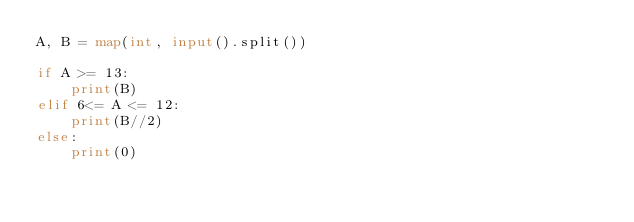Convert code to text. <code><loc_0><loc_0><loc_500><loc_500><_Python_>A, B = map(int, input().split())

if A >= 13:
    print(B)
elif 6<= A <= 12:
    print(B//2)
else:
    print(0)</code> 